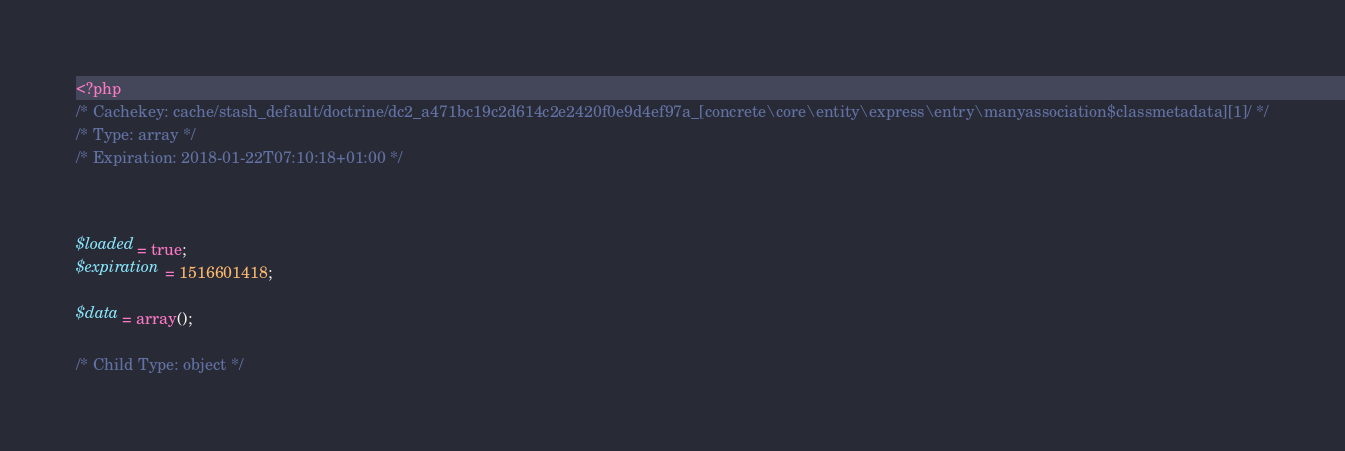Convert code to text. <code><loc_0><loc_0><loc_500><loc_500><_PHP_><?php 
/* Cachekey: cache/stash_default/doctrine/dc2_a471bc19c2d614c2e2420f0e9d4ef97a_[concrete\core\entity\express\entry\manyassociation$classmetadata][1]/ */
/* Type: array */
/* Expiration: 2018-01-22T07:10:18+01:00 */



$loaded = true;
$expiration = 1516601418;

$data = array();

/* Child Type: object */</code> 